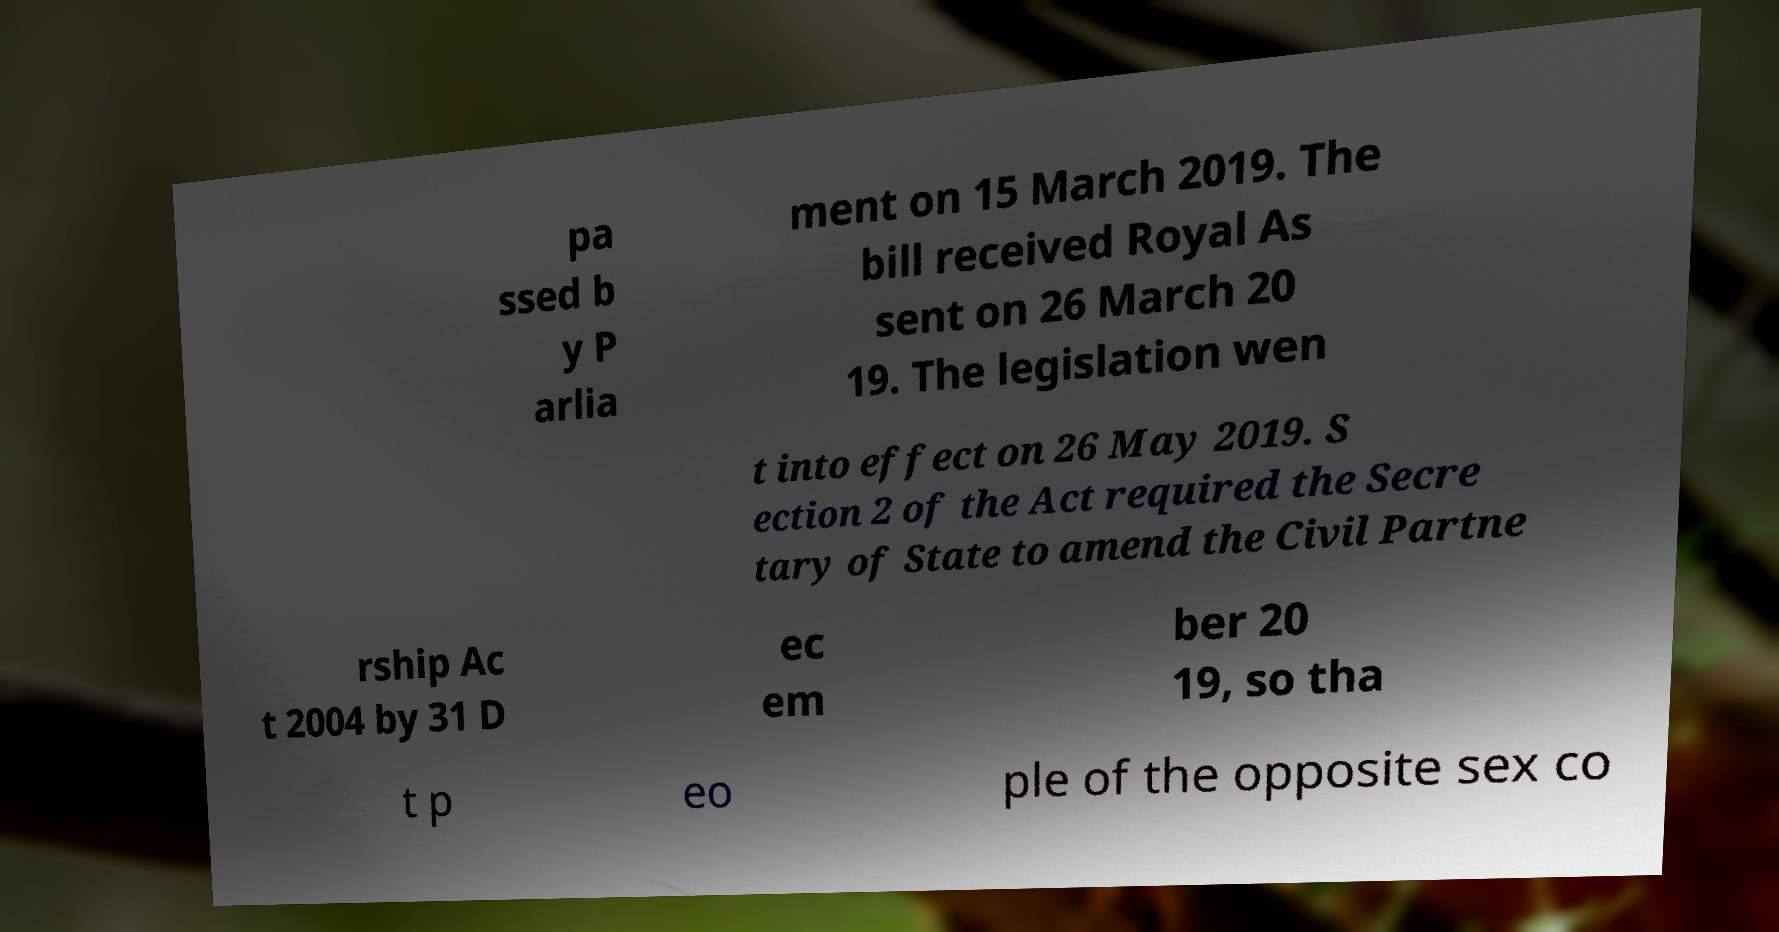What messages or text are displayed in this image? I need them in a readable, typed format. pa ssed b y P arlia ment on 15 March 2019. The bill received Royal As sent on 26 March 20 19. The legislation wen t into effect on 26 May 2019. S ection 2 of the Act required the Secre tary of State to amend the Civil Partne rship Ac t 2004 by 31 D ec em ber 20 19, so tha t p eo ple of the opposite sex co 